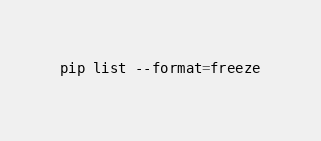Convert code to text. <code><loc_0><loc_0><loc_500><loc_500><_Bash_>pip list --format=freeze
</code> 